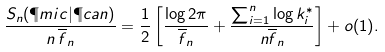Convert formula to latex. <formula><loc_0><loc_0><loc_500><loc_500>\frac { S _ { n } ( \P m i c | \P c a n ) } { n \, \overline { f } _ { n } } = \frac { 1 } { 2 } \left [ \frac { \log 2 \pi } { \overline { f } _ { n } } + \frac { \sum _ { i = 1 } ^ { n } \log k _ { i } ^ { * } } { n \overline { f } _ { n } } \right ] + o ( 1 ) .</formula> 